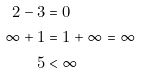<formula> <loc_0><loc_0><loc_500><loc_500>2 - 3 & = 0 \\ \infty + 1 & = 1 + \infty = \infty \\ 5 & < \infty</formula> 